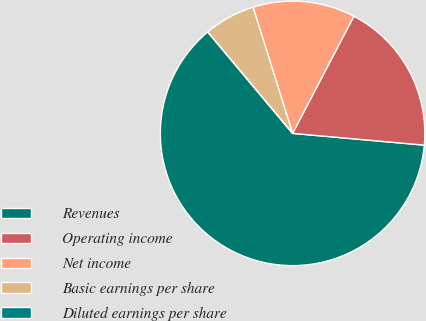Convert chart. <chart><loc_0><loc_0><loc_500><loc_500><pie_chart><fcel>Revenues<fcel>Operating income<fcel>Net income<fcel>Basic earnings per share<fcel>Diluted earnings per share<nl><fcel>62.5%<fcel>18.75%<fcel>12.5%<fcel>6.25%<fcel>0.0%<nl></chart> 